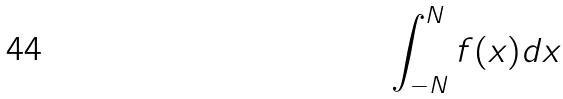<formula> <loc_0><loc_0><loc_500><loc_500>\int _ { - N } ^ { N } f ( x ) d x</formula> 